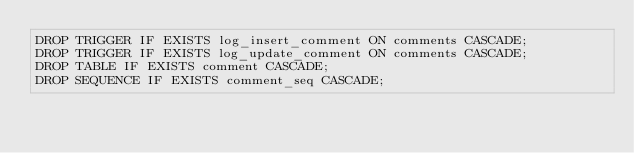<code> <loc_0><loc_0><loc_500><loc_500><_SQL_>DROP TRIGGER IF EXISTS log_insert_comment ON comments CASCADE;
DROP TRIGGER IF EXISTS log_update_comment ON comments CASCADE;
DROP TABLE IF EXISTS comment CASCADE;
DROP SEQUENCE IF EXISTS comment_seq CASCADE;</code> 